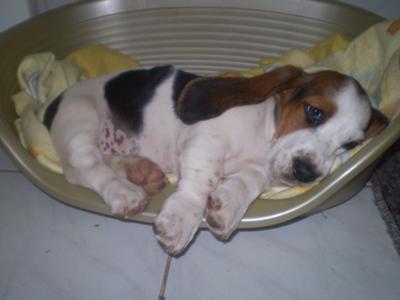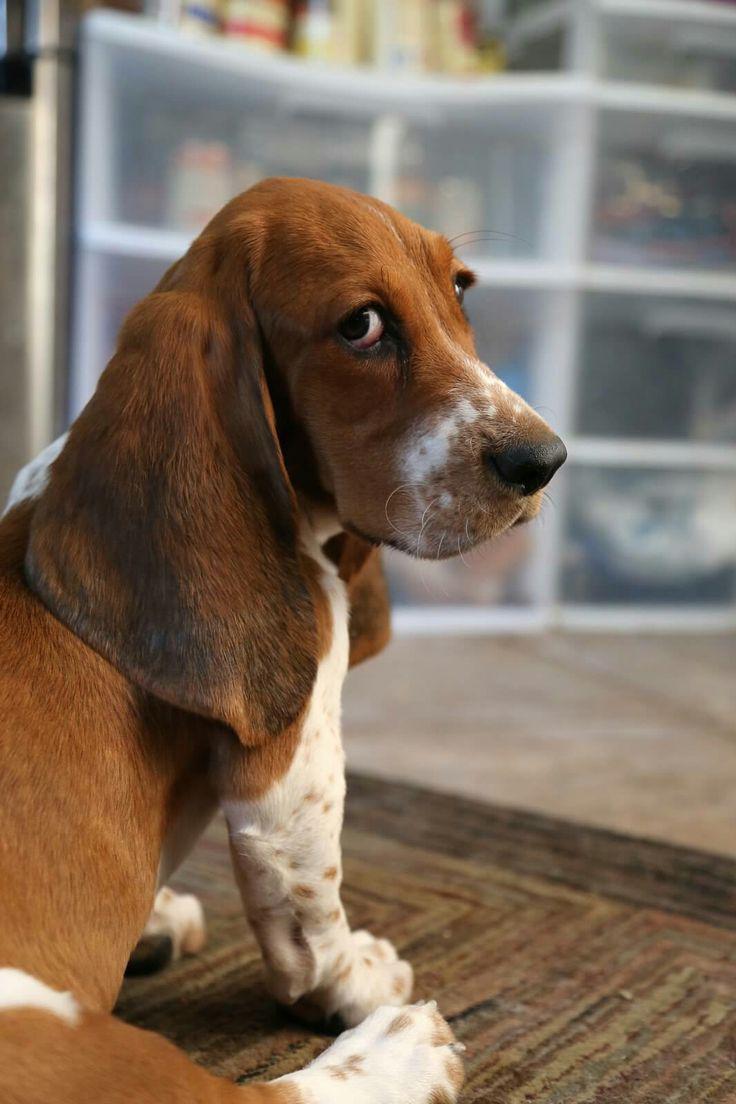The first image is the image on the left, the second image is the image on the right. Assess this claim about the two images: "The dog in the left image is laying down.". Correct or not? Answer yes or no. Yes. The first image is the image on the left, the second image is the image on the right. Examine the images to the left and right. Is the description "on the left picture the dog has their head laying down" accurate? Answer yes or no. Yes. 